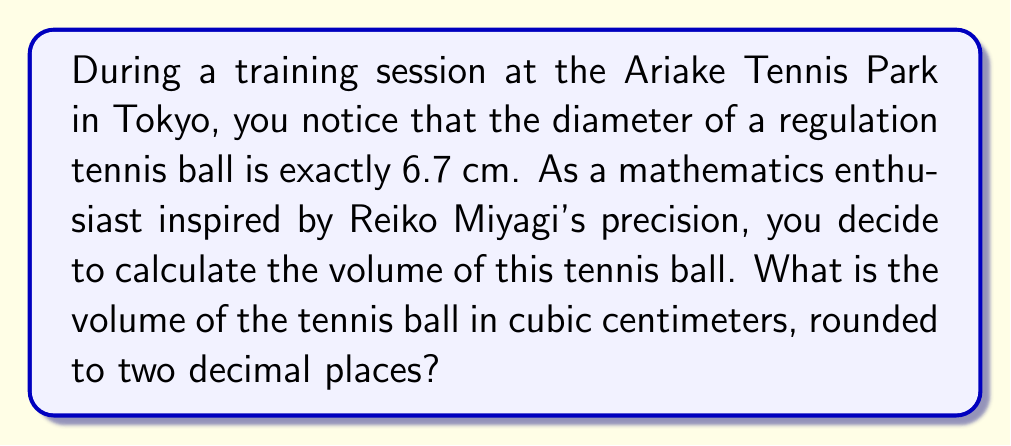Can you answer this question? Let's approach this step-by-step:

1) The formula for the volume of a sphere is:
   $$V = \frac{4}{3}\pi r^3$$
   where $r$ is the radius of the sphere.

2) We are given the diameter, which is 6.7 cm. The radius is half of the diameter:
   $$r = \frac{6.7}{2} = 3.35 \text{ cm}$$

3) Now, let's substitute this into our volume formula:
   $$V = \frac{4}{3}\pi (3.35)^3$$

4) Let's calculate this:
   $$V = \frac{4}{3} \cdot \pi \cdot 37.558125$$
   $$V = 4.1887902 \cdot 37.558125$$
   $$V = 157.2515 \text{ cm}^3$$

5) Rounding to two decimal places:
   $$V \approx 157.25 \text{ cm}^3$$
Answer: $157.25 \text{ cm}^3$ 